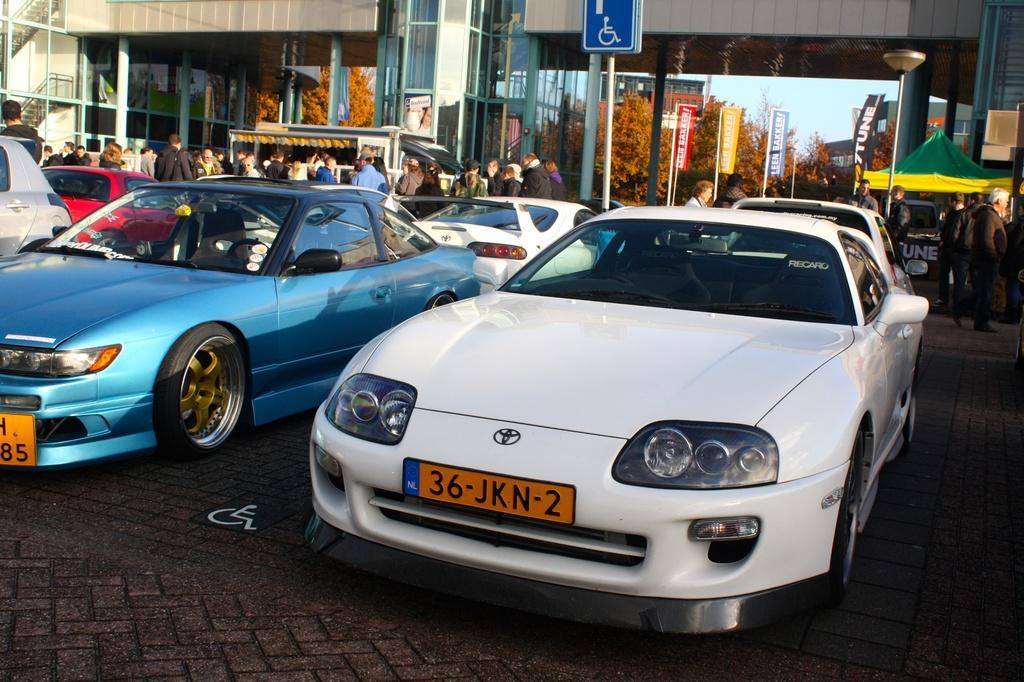How would you summarize this image in a sentence or two? In this picture I can see many cars which are parked near to the road. Beside that I can see many peoples who are walking on the street. In the background I can see the buildings, trees, banners, sign boards, bridge, poles, sky, tent and other objects. 